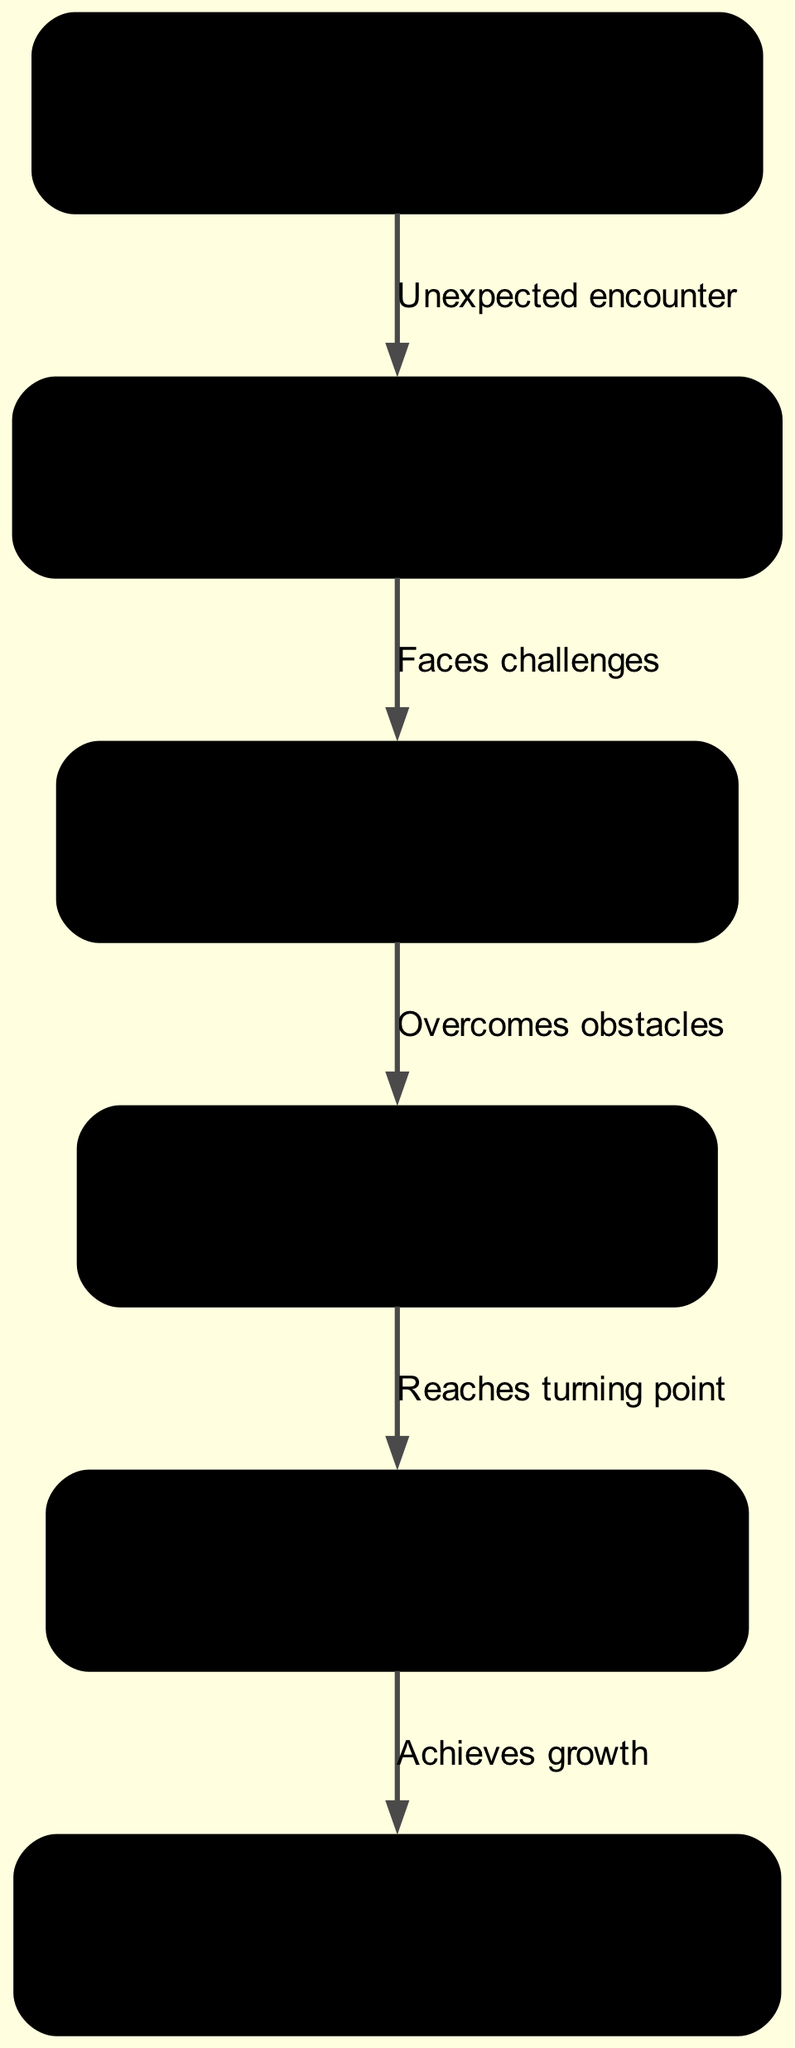What is the first stage of character development? The diagram indicates that the first stage is "Ordinary Life," as it is the starting node representing the character's mundane daily routine.
Answer: Ordinary Life How many stages are there in the character development? The diagram displays a total of 6 nodes, which correspond to the 6 stages of character development outlined in the diagram.
Answer: 6 What type of incident leads to the "Conflict"? The edge between "Inciting Incident" and "Conflict" is labeled "Faces challenges," indicating that it is incidents that create obstacles for the protagonist.
Answer: Faces challenges What is the pivotal moment of transformation called in this diagram? According to the diagram, the pivotal moment of transformation is labeled "Climax," which is the key stage where significant change occurs in the character's journey.
Answer: Climax Which stage comes after "Personal Growth"? The flow of the diagram shows that the stage following "Personal Growth" is "Climax," indicating this is where the character reaches a crucial point of evolution in their journey.
Answer: Climax What does the edge from "Conflict" to "Personal Growth" represent? The connection from "Conflict" to "Personal Growth" is labeled "Overcomes obstacles," signifying that the character must surpass difficulties to evolve.
Answer: Overcomes obstacles At which stage does the character achieve growth? The diagram clearly labels the last stage as "Resolution," highlighting where the character achieves their growth and gains a new perspective on life.
Answer: Resolution What is the last step of the character development process? According to the diagram, the last step or stage in this process is "Resolution," which is where the character reflects on their journey and integrates their growth.
Answer: Resolution 